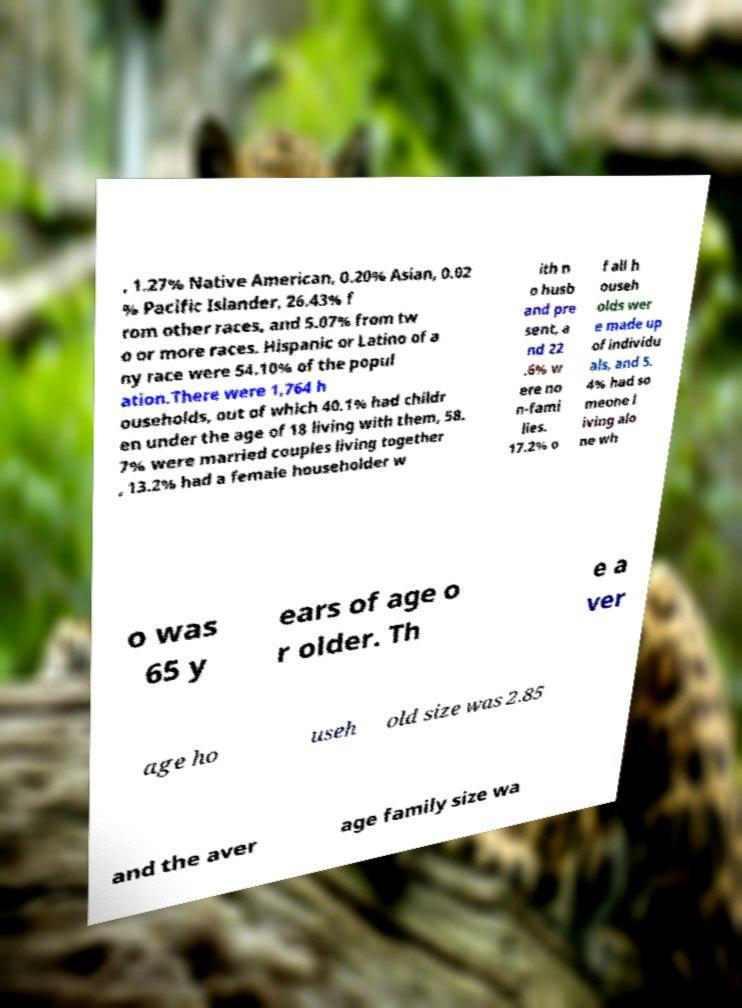Can you read and provide the text displayed in the image?This photo seems to have some interesting text. Can you extract and type it out for me? , 1.27% Native American, 0.20% Asian, 0.02 % Pacific Islander, 26.43% f rom other races, and 5.07% from tw o or more races. Hispanic or Latino of a ny race were 54.10% of the popul ation.There were 1,764 h ouseholds, out of which 40.1% had childr en under the age of 18 living with them, 58. 7% were married couples living together , 13.2% had a female householder w ith n o husb and pre sent, a nd 22 .6% w ere no n-fami lies. 17.2% o f all h ouseh olds wer e made up of individu als, and 5. 4% had so meone l iving alo ne wh o was 65 y ears of age o r older. Th e a ver age ho useh old size was 2.85 and the aver age family size wa 